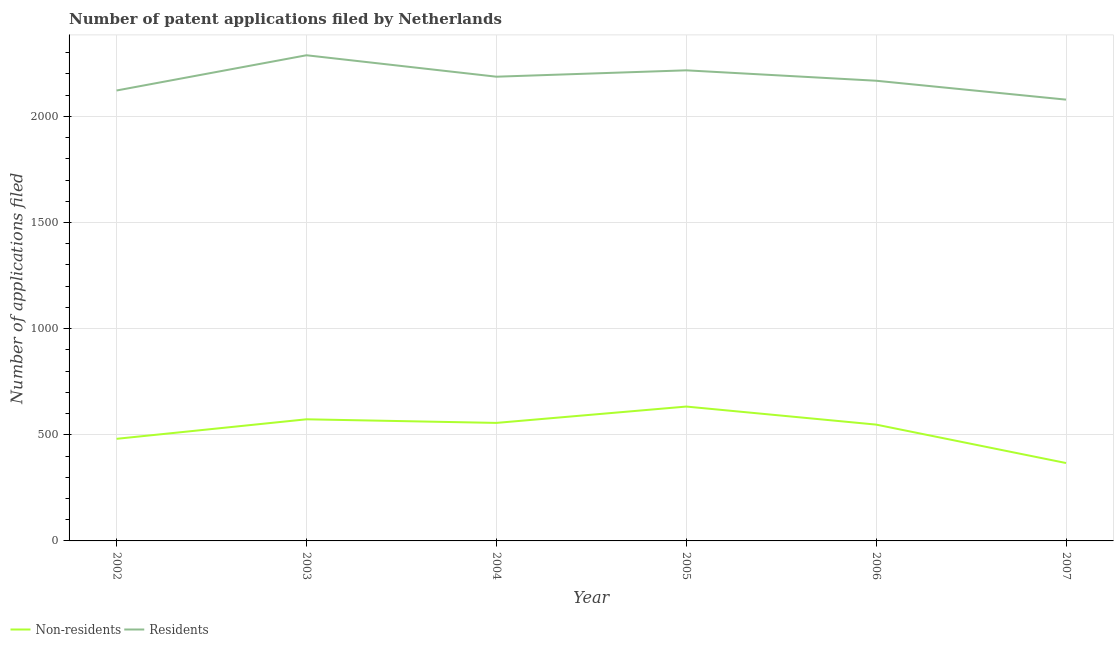How many different coloured lines are there?
Offer a terse response. 2. Does the line corresponding to number of patent applications by non residents intersect with the line corresponding to number of patent applications by residents?
Give a very brief answer. No. Is the number of lines equal to the number of legend labels?
Give a very brief answer. Yes. What is the number of patent applications by non residents in 2002?
Offer a terse response. 481. Across all years, what is the maximum number of patent applications by residents?
Give a very brief answer. 2288. Across all years, what is the minimum number of patent applications by non residents?
Your answer should be compact. 367. What is the total number of patent applications by non residents in the graph?
Offer a terse response. 3158. What is the difference between the number of patent applications by residents in 2006 and that in 2007?
Your response must be concise. 89. What is the difference between the number of patent applications by residents in 2007 and the number of patent applications by non residents in 2003?
Your answer should be very brief. 1506. What is the average number of patent applications by non residents per year?
Give a very brief answer. 526.33. In the year 2003, what is the difference between the number of patent applications by residents and number of patent applications by non residents?
Offer a very short reply. 1715. In how many years, is the number of patent applications by non residents greater than 300?
Offer a terse response. 6. What is the ratio of the number of patent applications by residents in 2002 to that in 2005?
Provide a short and direct response. 0.96. Is the number of patent applications by non residents in 2002 less than that in 2005?
Provide a short and direct response. Yes. Is the difference between the number of patent applications by non residents in 2002 and 2007 greater than the difference between the number of patent applications by residents in 2002 and 2007?
Your response must be concise. Yes. What is the difference between the highest and the second highest number of patent applications by residents?
Give a very brief answer. 71. What is the difference between the highest and the lowest number of patent applications by non residents?
Ensure brevity in your answer.  266. Does the number of patent applications by residents monotonically increase over the years?
Provide a short and direct response. No. Is the number of patent applications by non residents strictly less than the number of patent applications by residents over the years?
Provide a short and direct response. Yes. How many lines are there?
Keep it short and to the point. 2. What is the difference between two consecutive major ticks on the Y-axis?
Your answer should be compact. 500. Are the values on the major ticks of Y-axis written in scientific E-notation?
Ensure brevity in your answer.  No. Does the graph contain grids?
Give a very brief answer. Yes. Where does the legend appear in the graph?
Ensure brevity in your answer.  Bottom left. What is the title of the graph?
Give a very brief answer. Number of patent applications filed by Netherlands. What is the label or title of the X-axis?
Provide a succinct answer. Year. What is the label or title of the Y-axis?
Your response must be concise. Number of applications filed. What is the Number of applications filed in Non-residents in 2002?
Give a very brief answer. 481. What is the Number of applications filed in Residents in 2002?
Make the answer very short. 2122. What is the Number of applications filed of Non-residents in 2003?
Offer a terse response. 573. What is the Number of applications filed in Residents in 2003?
Provide a short and direct response. 2288. What is the Number of applications filed in Non-residents in 2004?
Offer a very short reply. 556. What is the Number of applications filed in Residents in 2004?
Make the answer very short. 2187. What is the Number of applications filed of Non-residents in 2005?
Your answer should be compact. 633. What is the Number of applications filed in Residents in 2005?
Offer a terse response. 2217. What is the Number of applications filed of Non-residents in 2006?
Make the answer very short. 548. What is the Number of applications filed of Residents in 2006?
Ensure brevity in your answer.  2168. What is the Number of applications filed in Non-residents in 2007?
Ensure brevity in your answer.  367. What is the Number of applications filed of Residents in 2007?
Provide a succinct answer. 2079. Across all years, what is the maximum Number of applications filed of Non-residents?
Offer a very short reply. 633. Across all years, what is the maximum Number of applications filed of Residents?
Give a very brief answer. 2288. Across all years, what is the minimum Number of applications filed in Non-residents?
Provide a succinct answer. 367. Across all years, what is the minimum Number of applications filed of Residents?
Make the answer very short. 2079. What is the total Number of applications filed of Non-residents in the graph?
Provide a short and direct response. 3158. What is the total Number of applications filed in Residents in the graph?
Offer a terse response. 1.31e+04. What is the difference between the Number of applications filed in Non-residents in 2002 and that in 2003?
Make the answer very short. -92. What is the difference between the Number of applications filed in Residents in 2002 and that in 2003?
Offer a terse response. -166. What is the difference between the Number of applications filed in Non-residents in 2002 and that in 2004?
Make the answer very short. -75. What is the difference between the Number of applications filed of Residents in 2002 and that in 2004?
Ensure brevity in your answer.  -65. What is the difference between the Number of applications filed of Non-residents in 2002 and that in 2005?
Make the answer very short. -152. What is the difference between the Number of applications filed in Residents in 2002 and that in 2005?
Offer a very short reply. -95. What is the difference between the Number of applications filed in Non-residents in 2002 and that in 2006?
Make the answer very short. -67. What is the difference between the Number of applications filed of Residents in 2002 and that in 2006?
Provide a short and direct response. -46. What is the difference between the Number of applications filed in Non-residents in 2002 and that in 2007?
Ensure brevity in your answer.  114. What is the difference between the Number of applications filed in Residents in 2002 and that in 2007?
Your answer should be compact. 43. What is the difference between the Number of applications filed in Residents in 2003 and that in 2004?
Make the answer very short. 101. What is the difference between the Number of applications filed of Non-residents in 2003 and that in 2005?
Your answer should be compact. -60. What is the difference between the Number of applications filed of Residents in 2003 and that in 2005?
Offer a terse response. 71. What is the difference between the Number of applications filed in Residents in 2003 and that in 2006?
Provide a short and direct response. 120. What is the difference between the Number of applications filed of Non-residents in 2003 and that in 2007?
Provide a succinct answer. 206. What is the difference between the Number of applications filed in Residents in 2003 and that in 2007?
Offer a terse response. 209. What is the difference between the Number of applications filed of Non-residents in 2004 and that in 2005?
Offer a very short reply. -77. What is the difference between the Number of applications filed in Residents in 2004 and that in 2005?
Make the answer very short. -30. What is the difference between the Number of applications filed in Residents in 2004 and that in 2006?
Provide a succinct answer. 19. What is the difference between the Number of applications filed in Non-residents in 2004 and that in 2007?
Give a very brief answer. 189. What is the difference between the Number of applications filed of Residents in 2004 and that in 2007?
Make the answer very short. 108. What is the difference between the Number of applications filed in Non-residents in 2005 and that in 2006?
Your answer should be very brief. 85. What is the difference between the Number of applications filed in Residents in 2005 and that in 2006?
Give a very brief answer. 49. What is the difference between the Number of applications filed in Non-residents in 2005 and that in 2007?
Ensure brevity in your answer.  266. What is the difference between the Number of applications filed of Residents in 2005 and that in 2007?
Ensure brevity in your answer.  138. What is the difference between the Number of applications filed in Non-residents in 2006 and that in 2007?
Provide a succinct answer. 181. What is the difference between the Number of applications filed of Residents in 2006 and that in 2007?
Provide a succinct answer. 89. What is the difference between the Number of applications filed of Non-residents in 2002 and the Number of applications filed of Residents in 2003?
Offer a very short reply. -1807. What is the difference between the Number of applications filed in Non-residents in 2002 and the Number of applications filed in Residents in 2004?
Your answer should be very brief. -1706. What is the difference between the Number of applications filed in Non-residents in 2002 and the Number of applications filed in Residents in 2005?
Your response must be concise. -1736. What is the difference between the Number of applications filed in Non-residents in 2002 and the Number of applications filed in Residents in 2006?
Provide a succinct answer. -1687. What is the difference between the Number of applications filed in Non-residents in 2002 and the Number of applications filed in Residents in 2007?
Provide a short and direct response. -1598. What is the difference between the Number of applications filed of Non-residents in 2003 and the Number of applications filed of Residents in 2004?
Your answer should be compact. -1614. What is the difference between the Number of applications filed of Non-residents in 2003 and the Number of applications filed of Residents in 2005?
Provide a short and direct response. -1644. What is the difference between the Number of applications filed in Non-residents in 2003 and the Number of applications filed in Residents in 2006?
Keep it short and to the point. -1595. What is the difference between the Number of applications filed in Non-residents in 2003 and the Number of applications filed in Residents in 2007?
Your answer should be compact. -1506. What is the difference between the Number of applications filed of Non-residents in 2004 and the Number of applications filed of Residents in 2005?
Make the answer very short. -1661. What is the difference between the Number of applications filed in Non-residents in 2004 and the Number of applications filed in Residents in 2006?
Make the answer very short. -1612. What is the difference between the Number of applications filed in Non-residents in 2004 and the Number of applications filed in Residents in 2007?
Ensure brevity in your answer.  -1523. What is the difference between the Number of applications filed in Non-residents in 2005 and the Number of applications filed in Residents in 2006?
Your response must be concise. -1535. What is the difference between the Number of applications filed in Non-residents in 2005 and the Number of applications filed in Residents in 2007?
Your answer should be compact. -1446. What is the difference between the Number of applications filed in Non-residents in 2006 and the Number of applications filed in Residents in 2007?
Your response must be concise. -1531. What is the average Number of applications filed in Non-residents per year?
Your answer should be very brief. 526.33. What is the average Number of applications filed in Residents per year?
Provide a short and direct response. 2176.83. In the year 2002, what is the difference between the Number of applications filed of Non-residents and Number of applications filed of Residents?
Offer a terse response. -1641. In the year 2003, what is the difference between the Number of applications filed of Non-residents and Number of applications filed of Residents?
Give a very brief answer. -1715. In the year 2004, what is the difference between the Number of applications filed of Non-residents and Number of applications filed of Residents?
Provide a short and direct response. -1631. In the year 2005, what is the difference between the Number of applications filed of Non-residents and Number of applications filed of Residents?
Ensure brevity in your answer.  -1584. In the year 2006, what is the difference between the Number of applications filed of Non-residents and Number of applications filed of Residents?
Offer a terse response. -1620. In the year 2007, what is the difference between the Number of applications filed in Non-residents and Number of applications filed in Residents?
Provide a succinct answer. -1712. What is the ratio of the Number of applications filed in Non-residents in 2002 to that in 2003?
Keep it short and to the point. 0.84. What is the ratio of the Number of applications filed in Residents in 2002 to that in 2003?
Provide a succinct answer. 0.93. What is the ratio of the Number of applications filed in Non-residents in 2002 to that in 2004?
Your response must be concise. 0.87. What is the ratio of the Number of applications filed of Residents in 2002 to that in 2004?
Keep it short and to the point. 0.97. What is the ratio of the Number of applications filed of Non-residents in 2002 to that in 2005?
Your response must be concise. 0.76. What is the ratio of the Number of applications filed of Residents in 2002 to that in 2005?
Give a very brief answer. 0.96. What is the ratio of the Number of applications filed in Non-residents in 2002 to that in 2006?
Your response must be concise. 0.88. What is the ratio of the Number of applications filed of Residents in 2002 to that in 2006?
Ensure brevity in your answer.  0.98. What is the ratio of the Number of applications filed in Non-residents in 2002 to that in 2007?
Keep it short and to the point. 1.31. What is the ratio of the Number of applications filed of Residents in 2002 to that in 2007?
Keep it short and to the point. 1.02. What is the ratio of the Number of applications filed of Non-residents in 2003 to that in 2004?
Keep it short and to the point. 1.03. What is the ratio of the Number of applications filed in Residents in 2003 to that in 2004?
Your answer should be compact. 1.05. What is the ratio of the Number of applications filed in Non-residents in 2003 to that in 2005?
Offer a very short reply. 0.91. What is the ratio of the Number of applications filed of Residents in 2003 to that in 2005?
Make the answer very short. 1.03. What is the ratio of the Number of applications filed of Non-residents in 2003 to that in 2006?
Provide a short and direct response. 1.05. What is the ratio of the Number of applications filed in Residents in 2003 to that in 2006?
Give a very brief answer. 1.06. What is the ratio of the Number of applications filed in Non-residents in 2003 to that in 2007?
Provide a short and direct response. 1.56. What is the ratio of the Number of applications filed in Residents in 2003 to that in 2007?
Provide a succinct answer. 1.1. What is the ratio of the Number of applications filed in Non-residents in 2004 to that in 2005?
Ensure brevity in your answer.  0.88. What is the ratio of the Number of applications filed of Residents in 2004 to that in 2005?
Your response must be concise. 0.99. What is the ratio of the Number of applications filed in Non-residents in 2004 to that in 2006?
Keep it short and to the point. 1.01. What is the ratio of the Number of applications filed of Residents in 2004 to that in 2006?
Ensure brevity in your answer.  1.01. What is the ratio of the Number of applications filed of Non-residents in 2004 to that in 2007?
Your response must be concise. 1.51. What is the ratio of the Number of applications filed in Residents in 2004 to that in 2007?
Your response must be concise. 1.05. What is the ratio of the Number of applications filed of Non-residents in 2005 to that in 2006?
Ensure brevity in your answer.  1.16. What is the ratio of the Number of applications filed of Residents in 2005 to that in 2006?
Your answer should be compact. 1.02. What is the ratio of the Number of applications filed in Non-residents in 2005 to that in 2007?
Your answer should be very brief. 1.72. What is the ratio of the Number of applications filed of Residents in 2005 to that in 2007?
Your response must be concise. 1.07. What is the ratio of the Number of applications filed in Non-residents in 2006 to that in 2007?
Provide a succinct answer. 1.49. What is the ratio of the Number of applications filed in Residents in 2006 to that in 2007?
Give a very brief answer. 1.04. What is the difference between the highest and the second highest Number of applications filed in Residents?
Your response must be concise. 71. What is the difference between the highest and the lowest Number of applications filed of Non-residents?
Offer a very short reply. 266. What is the difference between the highest and the lowest Number of applications filed in Residents?
Your answer should be very brief. 209. 